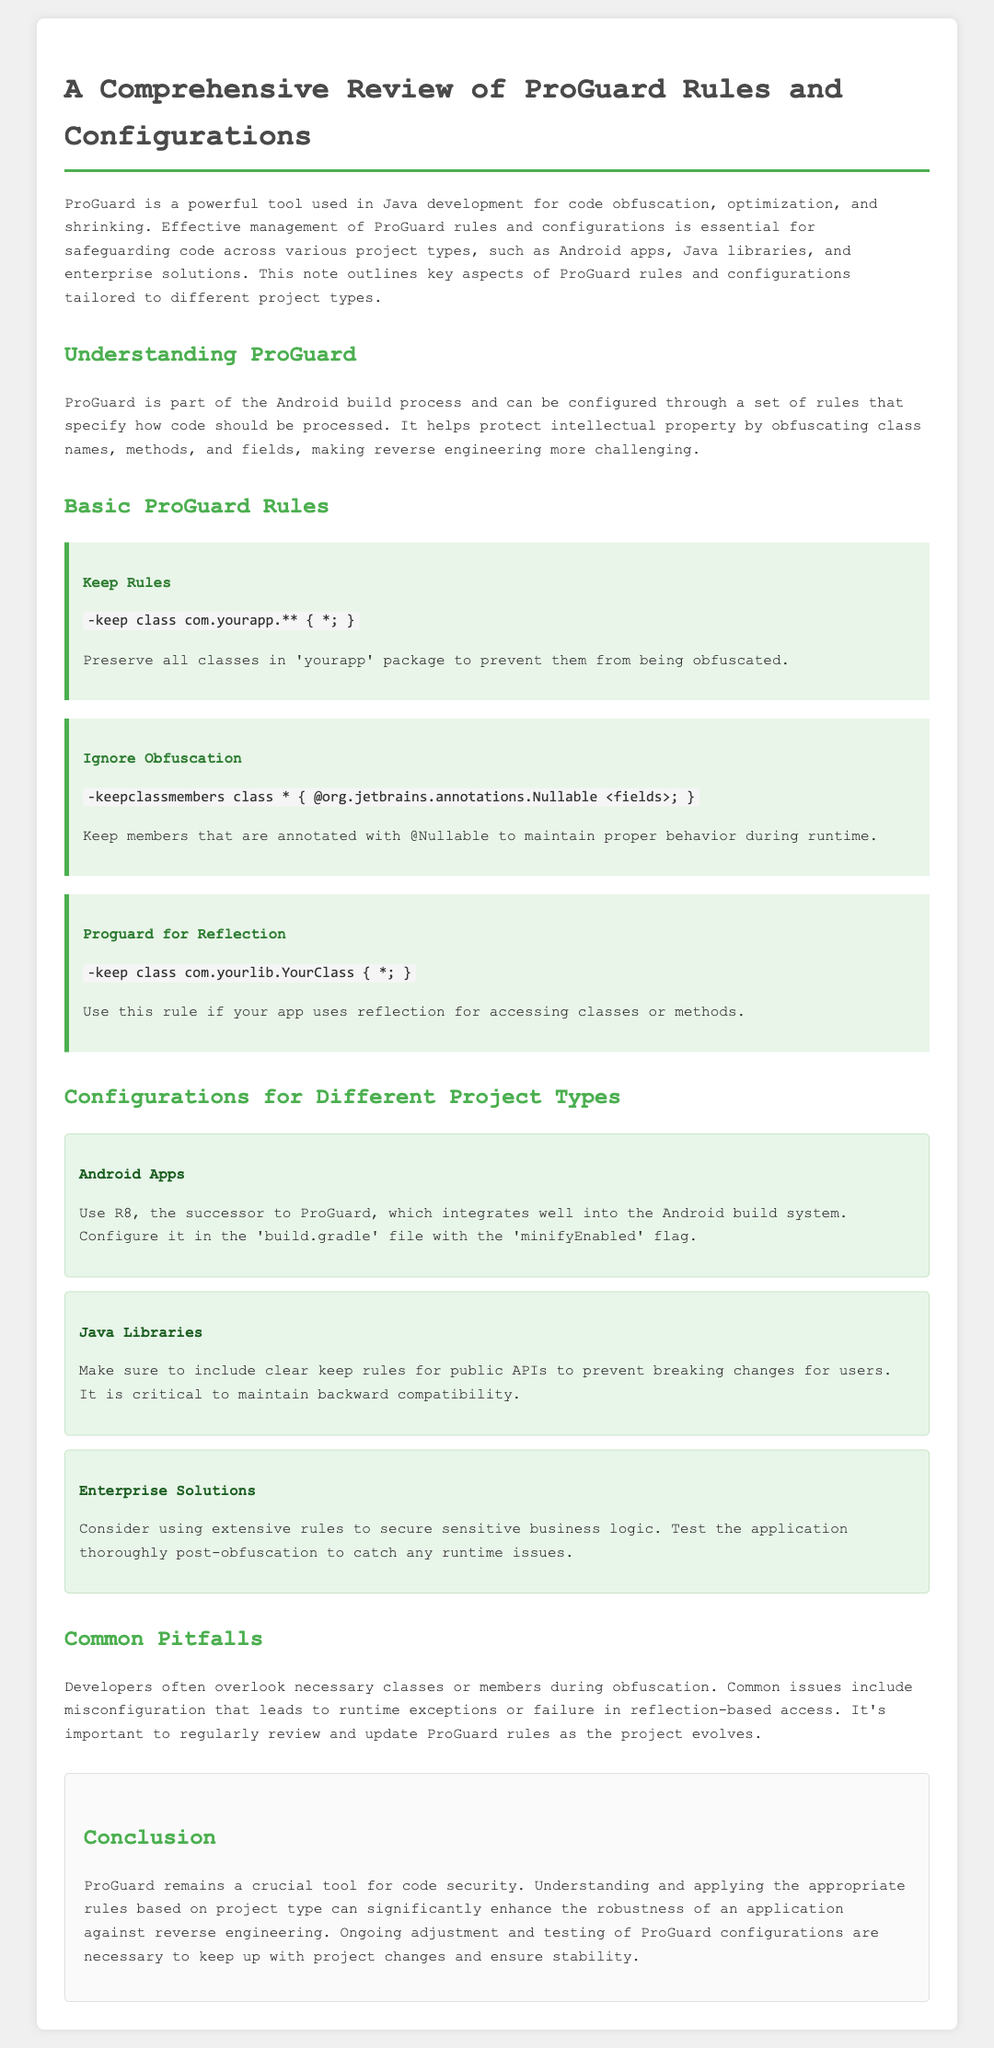What is the main purpose of ProGuard? ProGuard is primarily used for code obfuscation, optimization, and shrinking in Java development.
Answer: Code obfuscation, optimization, and shrinking What is the rule to preserve all classes in the 'yourapp' package? The document states the specific ProGuard rule used for this purpose, which is the keep rule.
Answer: -keep class com.yourapp.** { *; } Which type of projects should use R8? The note specifies that R8 is used for Android apps and integrates well into the Android build system.
Answer: Android Apps What is a common pitfall developers face when using ProGuard? The document talks about overlooking necessary classes or members, which leads to runtime exceptions.
Answer: Overlooking necessary classes or members How should Java libraries handle public APIs in ProGuard? The document advises including clear keep rules to prevent breaking changes for users of the library.
Answer: Clear keep rules for public APIs What is important to test after applying ProGuard rules in enterprise solutions? The document emphasizes the need to test the application thoroughly post-obfuscation to catch runtime issues.
Answer: Application stability What annotation should be kept according to the ignore obfuscation rule? This question refers to the specific annotation mentioned in the ProGuard rule regarding member preservation.
Answer: @Nullable Which section follows the Basic ProGuard Rules? The document outlines different configurations that follow the basic rules section.
Answer: Configurations for Different Project Types 